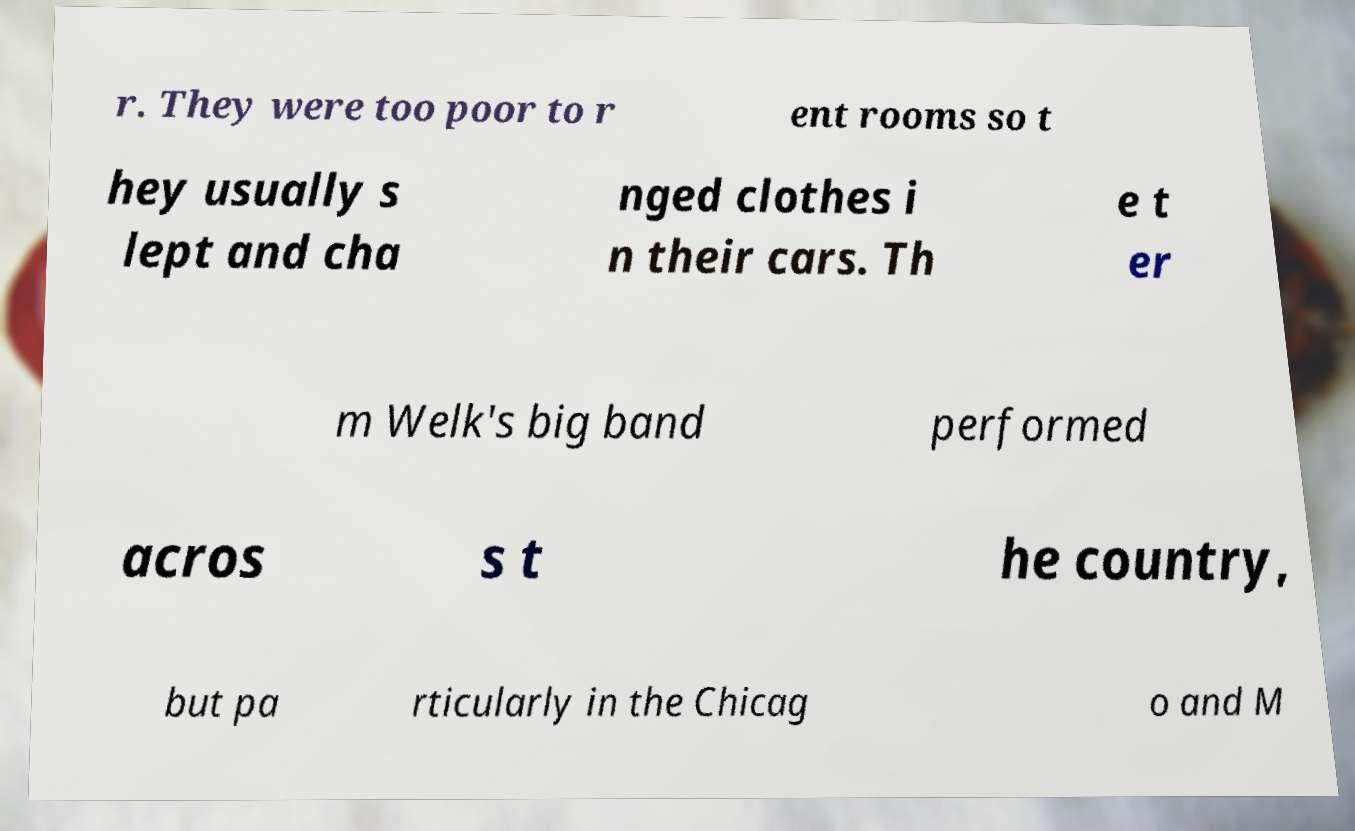Please identify and transcribe the text found in this image. r. They were too poor to r ent rooms so t hey usually s lept and cha nged clothes i n their cars. Th e t er m Welk's big band performed acros s t he country, but pa rticularly in the Chicag o and M 